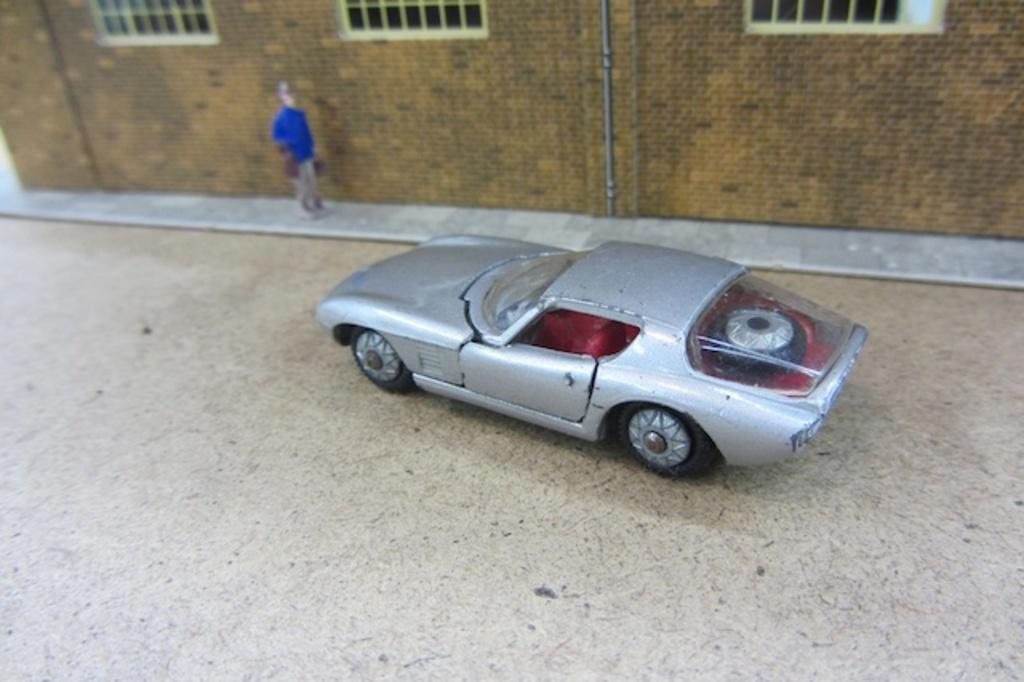Can you describe this image briefly? In this picture we can see a toy car on the floor and there is a person. In the background we can see a building. 